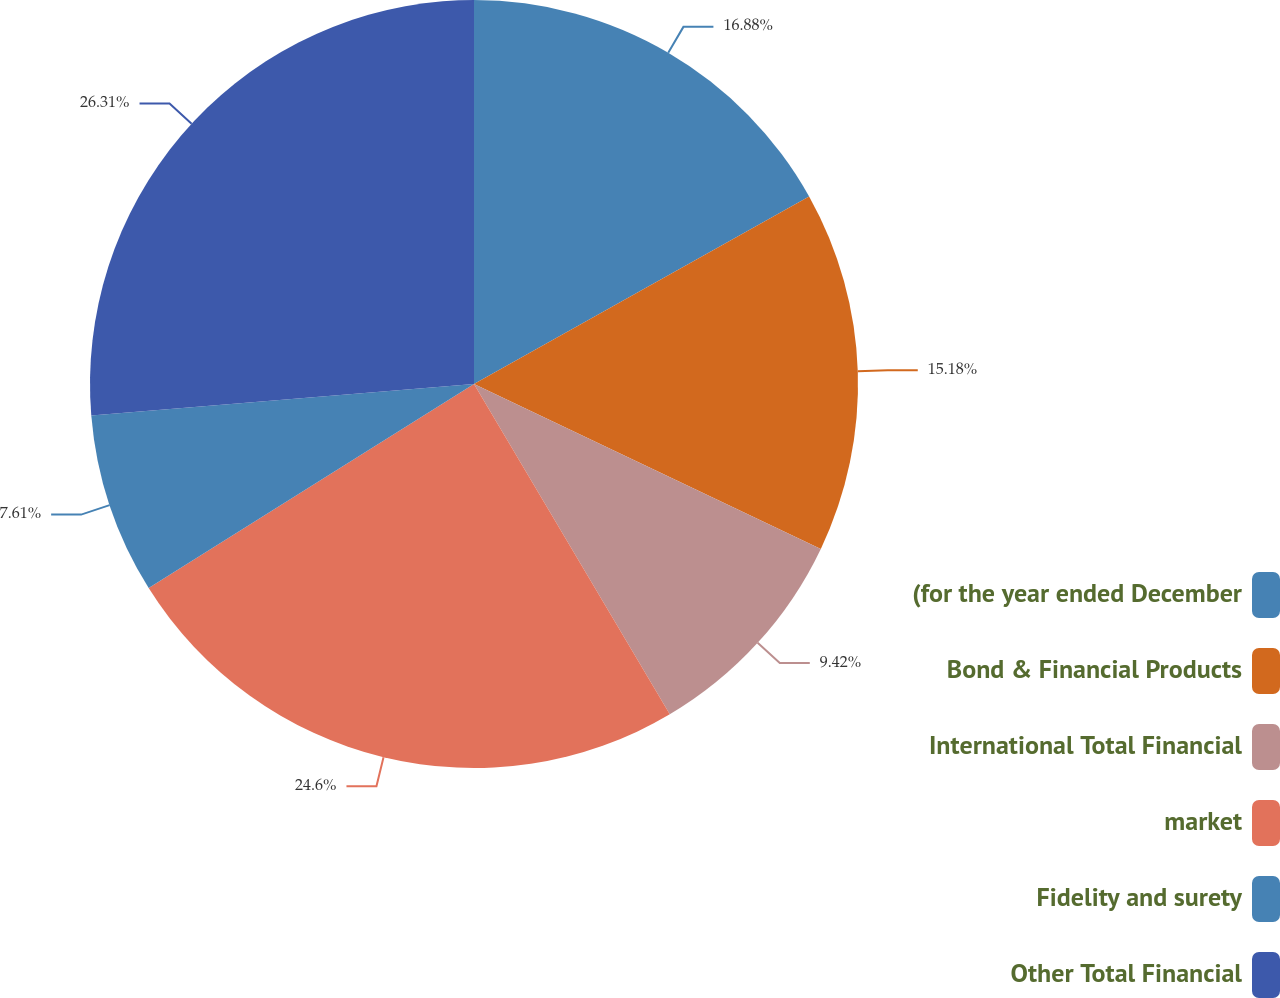<chart> <loc_0><loc_0><loc_500><loc_500><pie_chart><fcel>(for the year ended December<fcel>Bond & Financial Products<fcel>International Total Financial<fcel>market<fcel>Fidelity and surety<fcel>Other Total Financial<nl><fcel>16.88%<fcel>15.18%<fcel>9.42%<fcel>24.6%<fcel>7.61%<fcel>26.3%<nl></chart> 